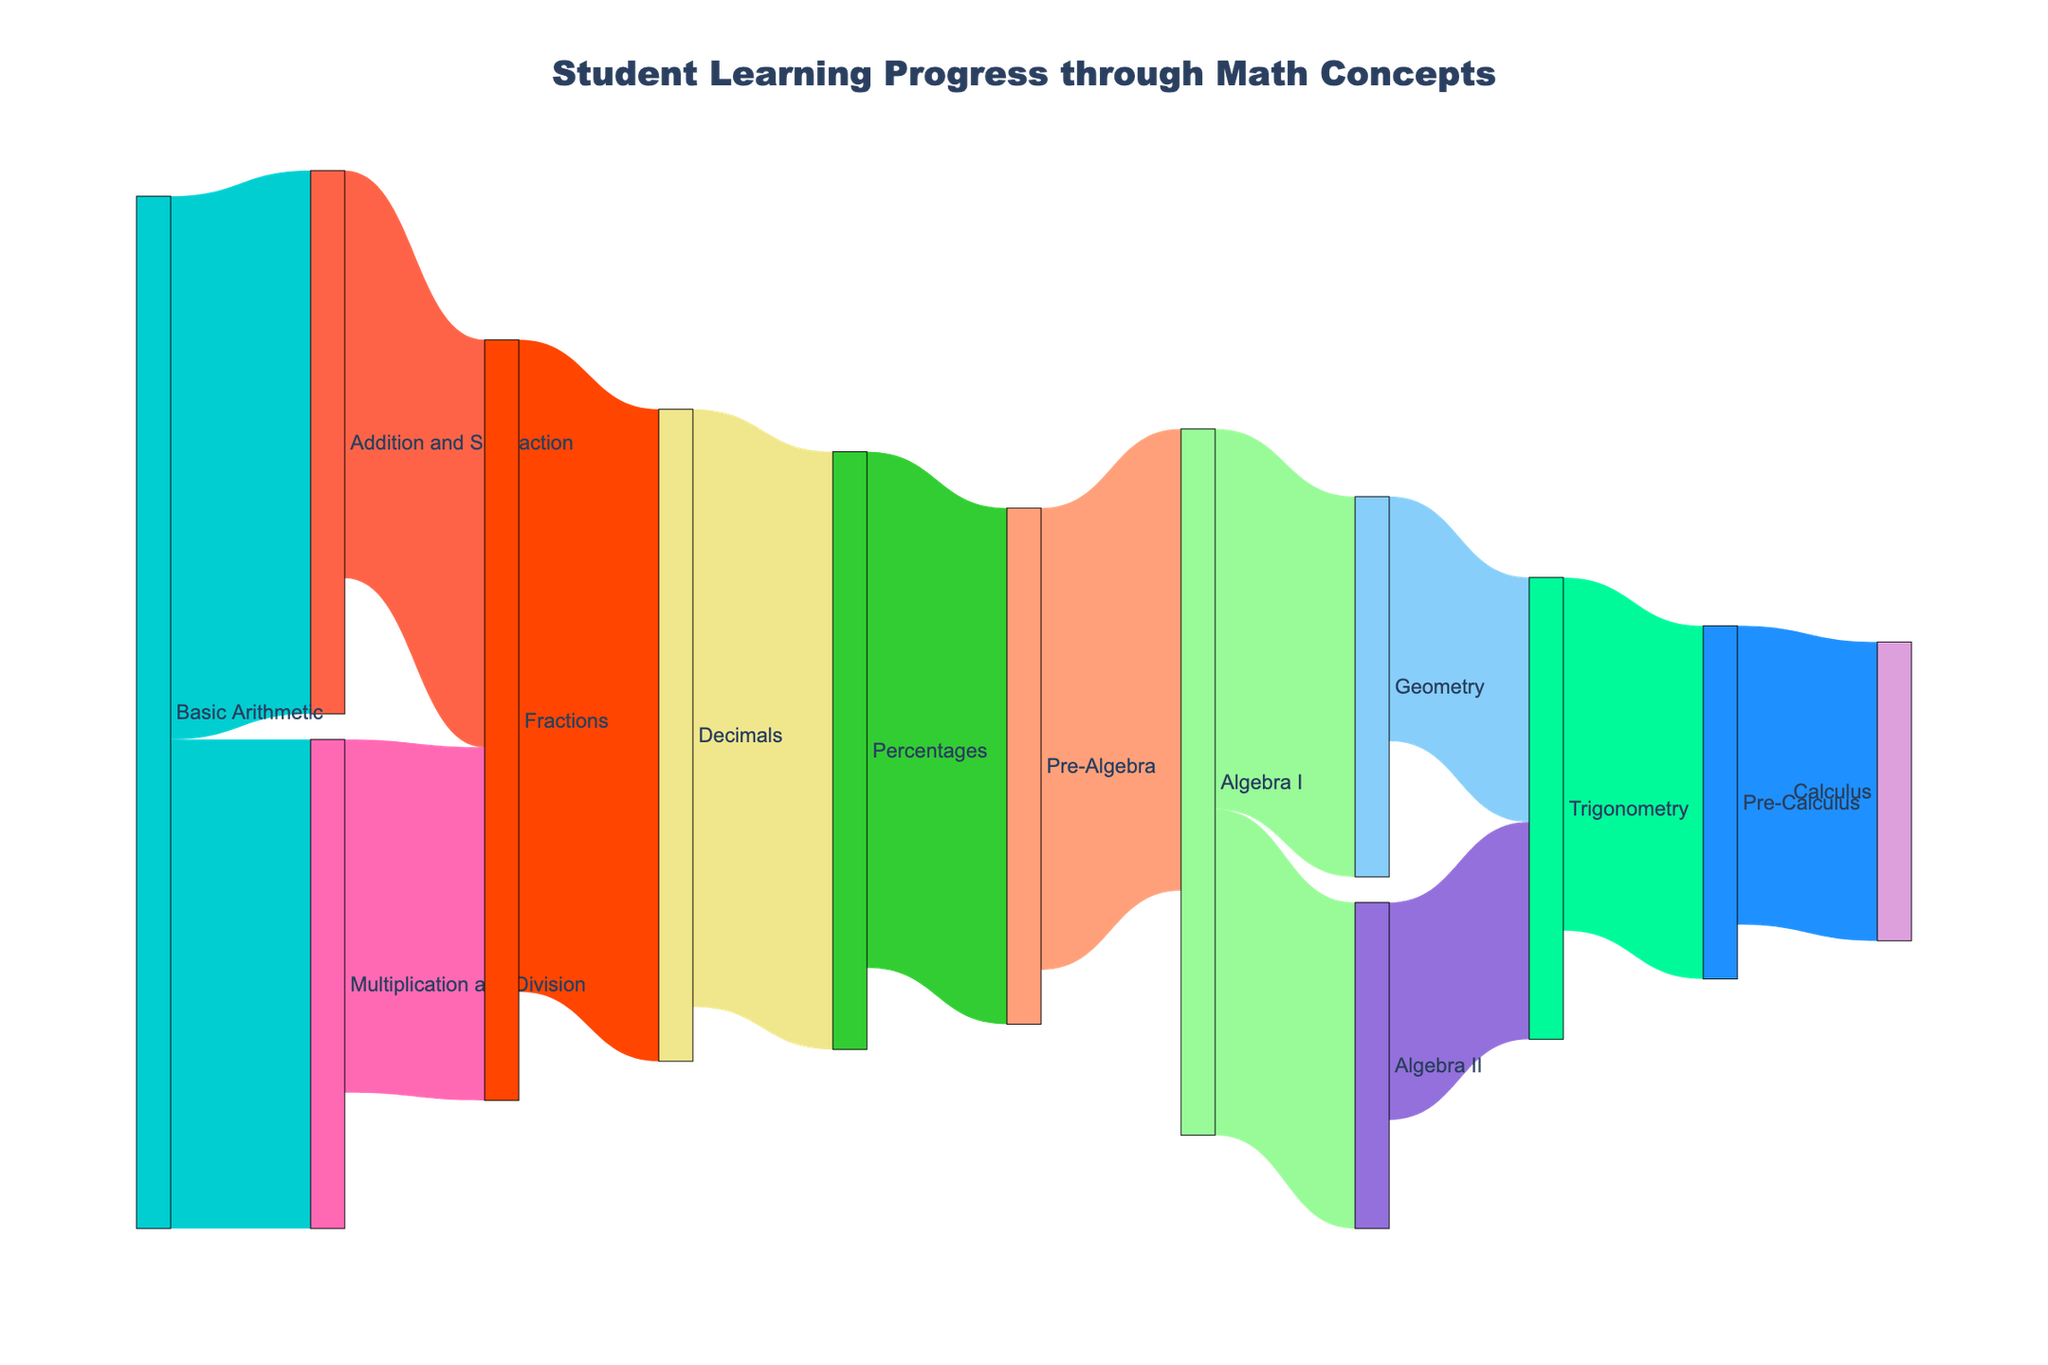What is the title of the figure? The title is usually located at the top of the figure and typically summarizes the content represented.
Answer: Student Learning Progress through Math Concepts How many students progressed from Basic Arithmetic to Addition and Subtraction? The value representing the link from "Basic Arithmetic" to "Addition and Subtraction" shows the number of students who progressed through these concepts.
Answer: 100 Which concept had the least number of students progressing to it from Algebra I? To find this, look at the links originating from "Algebra I" and compare their values.
Answer: Algebra II What's the total number of students who progressed from Fractions to Decimals and from Decimals to Percentages? Sum the values of the links from "Fractions" to "Decimals" and from "Decimals" to "Percentages".
Answer: 230 Which advanced math concept did more students reach: Pre-Calculus or Calculus? Compare the values of links leading to "Pre-Calculus" and "Calculus".
Answer: Pre-Calculus Which path had fewer students, from Pre-Algebra to Algebra I or from Geometry to Trigonometry? Compare the values of the links leading from "Pre-Algebra" to "Algebra I" and from "Geometry" to "Trigonometry".
Answer: Geometry to Trigonometry How many students progressed through Algebra I to reach Trigonometry eventually? Follow the path from "Algebra I" to "Trigonometry": Algebra I to Algebra II to Trigonometry. Add the values of these paths.
Answer: 40 What is the total number of students that started with Basic Arithmetic? Add the values of the links emerging from "Basic Arithmetic".
Answer: 190 Which topic had more flow into it: Fractions or Decimals? Compare the incoming links' values for "Fractions" and "Decimals".
Answer: Decimals How many students moved from Algebra II to Trigonometry compared to those who went from Geometry to Trigonometry? Compare the values of the links from "Algebra II" to "Trigonometry" and "Geometry" to "Trigonometry".
Answer: Geometry to Trigonometry had 45 while Algebra II to Trigonometry had 40 